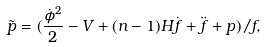<formula> <loc_0><loc_0><loc_500><loc_500>\tilde { p } = ( \frac { \dot { \phi } ^ { 2 } } { 2 } - V + ( n - 1 ) H \dot { f } + \ddot { f } + p ) / f ,</formula> 